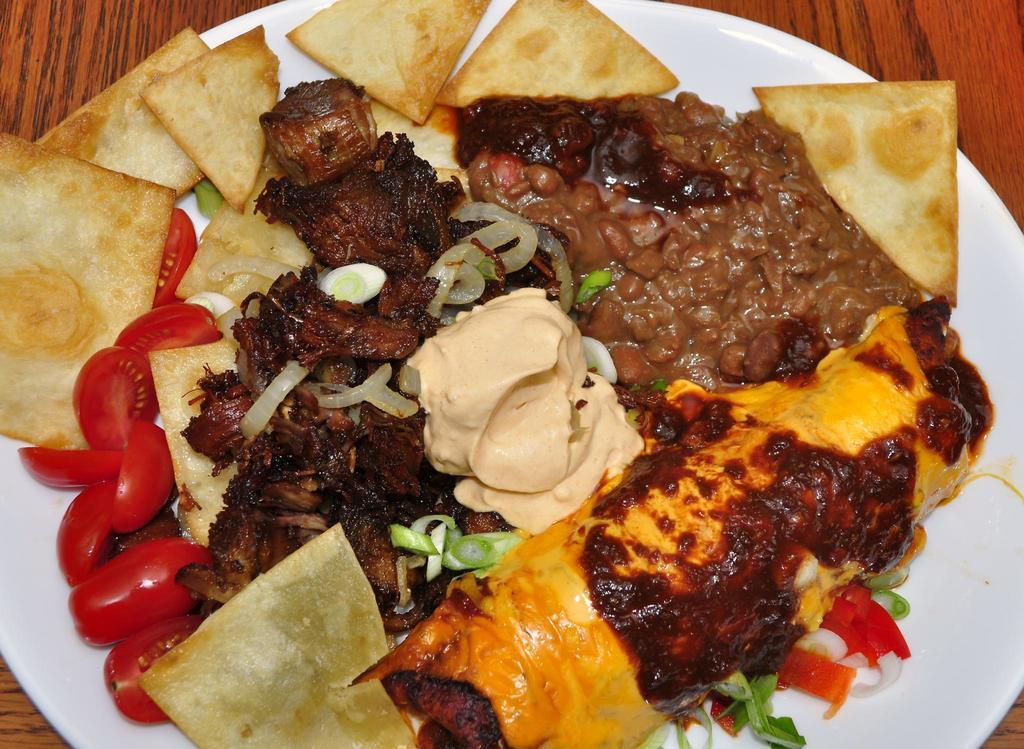What is on the table in the image? There is a plate on the table in the image. What is on the plate? The plate contains tomato pieces, meat pieces, onion slices, and chips. Is there any sauce or dressing on the plate? Yes, there is cream in the middle of the plate. Can you see a mountain in the background of the image? There is no mountain visible in the image. What type of trade is being conducted in the image? There is no trade being conducted in the image; it features a plate with various food items. 